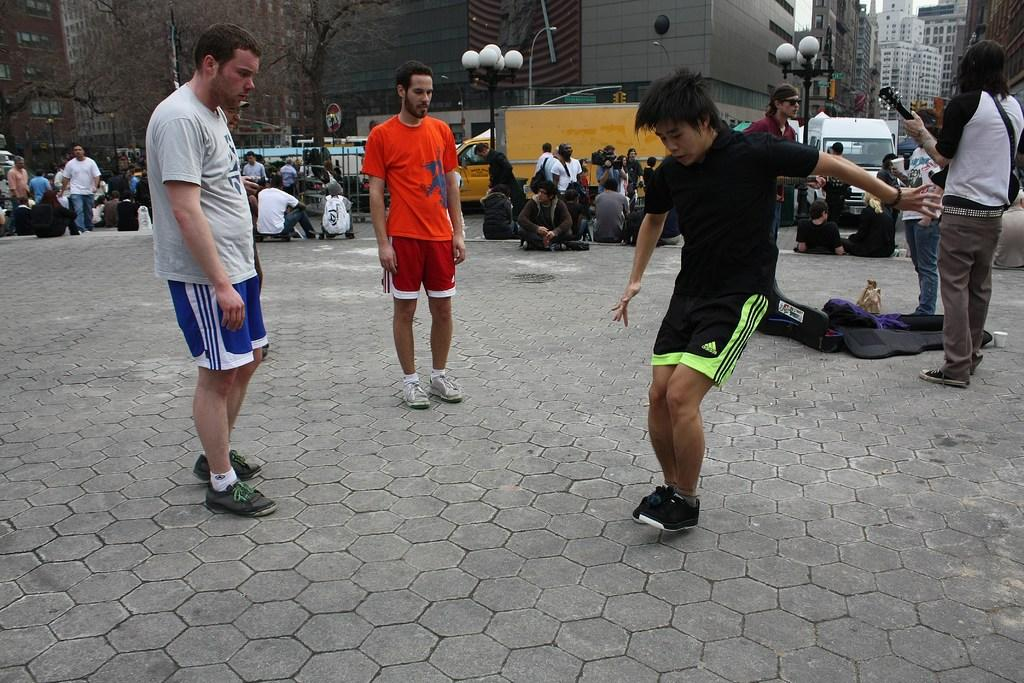How many people can be seen in the image? There are people in the image, but the exact number is not specified. What objects are the people carrying in the image? The people are carrying bags in the image. What structures are present in the image? There are poles and buildings in the image. What type of illumination is present in the image? There are lights in the image. What type of transportation is visible in the image? There are vehicles in the image. What type of vegetation is present in the image? There are trees in the image. What type of surface is visible in the image? There is ground visible in the image. What type of background can be seen in the image? There are buildings, boards, and sky visible in the background of the image. Can you tell me how many stems are growing from the trees in the image? There is no information about stems growing from the trees in the image. Is there a river flowing through the image? There is no river present in the image. 